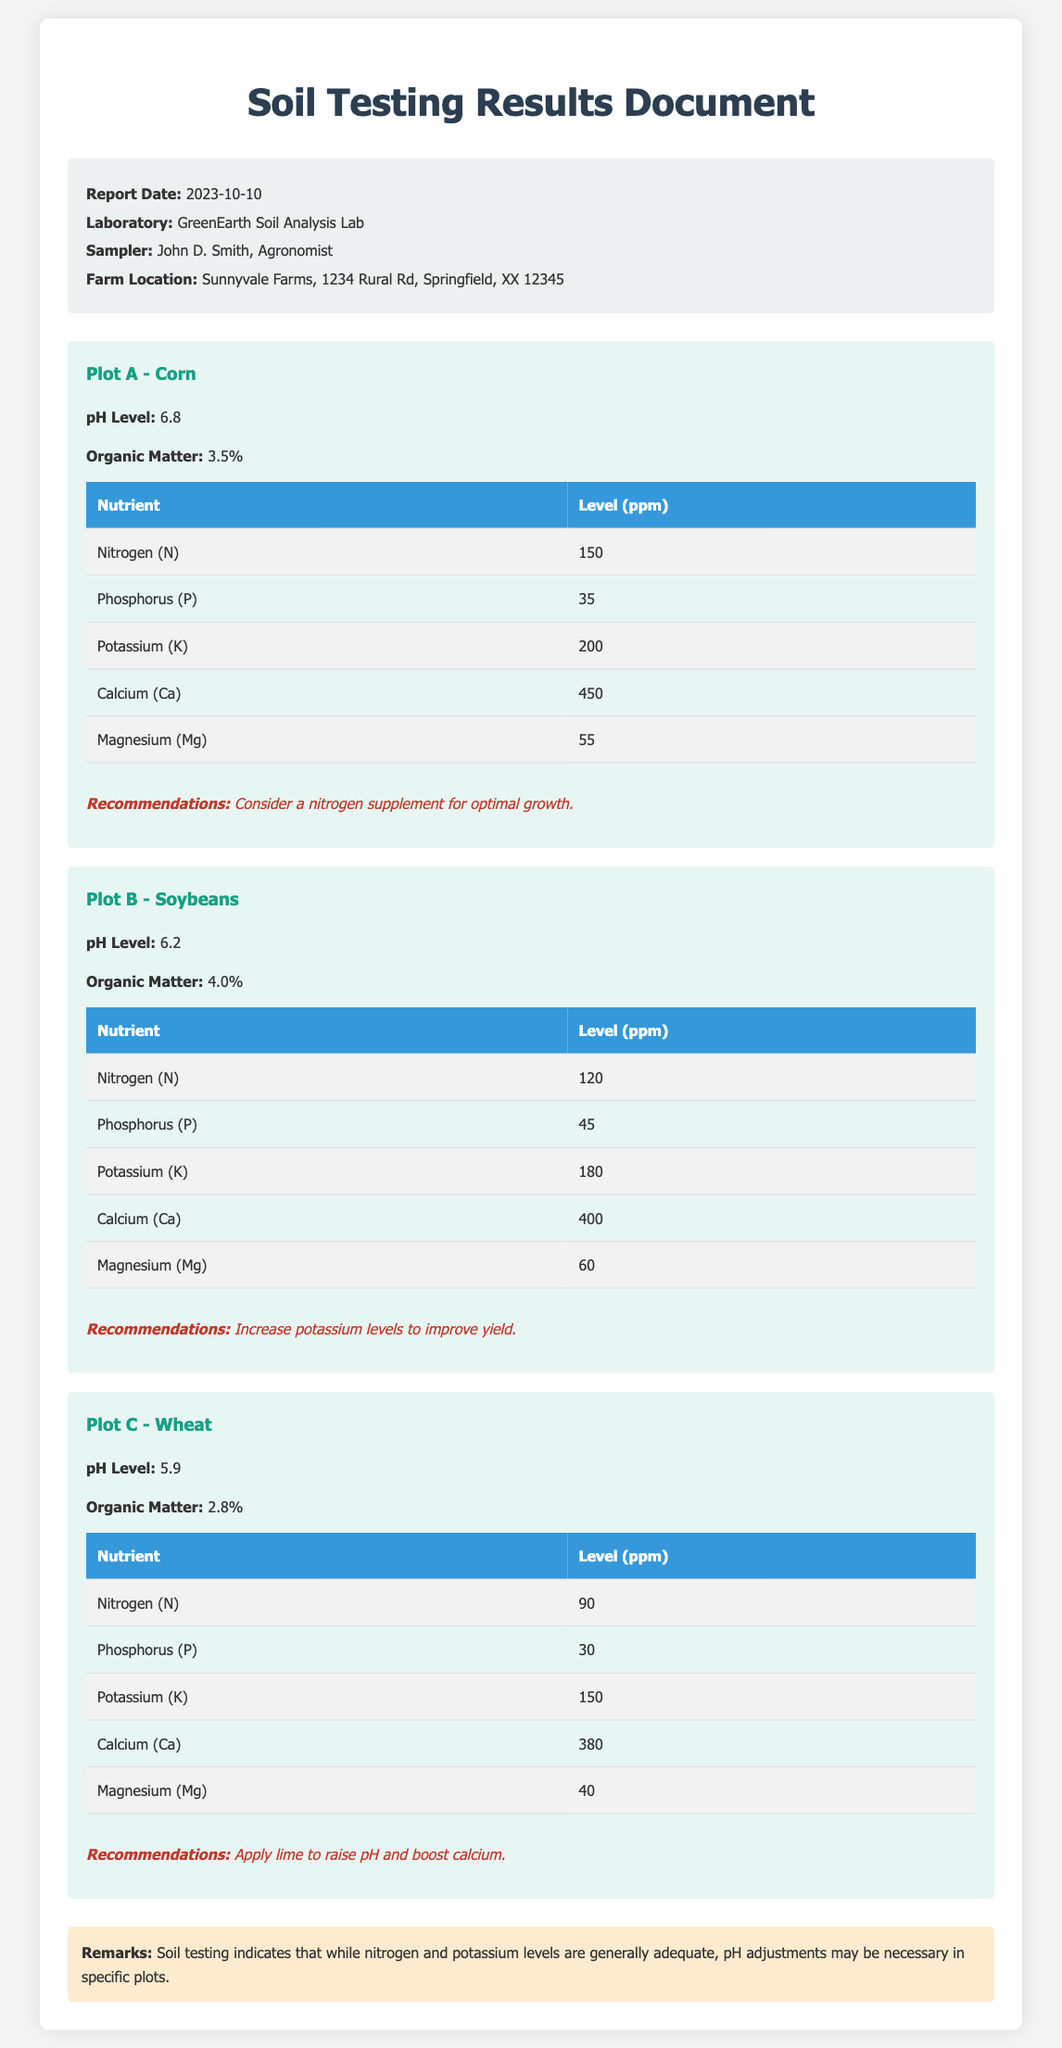What is the report date? The report date is mentioned in the header of the document as 2023-10-10.
Answer: 2023-10-10 What laboratory conducted the soil analysis? The document specifies that the laboratory is GreenEarth Soil Analysis Lab.
Answer: GreenEarth Soil Analysis Lab What is the pH level of Plot A? The pH level for Plot A is detailed in the section for Plot A as 6.8.
Answer: 6.8 What are the nitrogen levels in Plot B? The nitrogen level for Plot B is listed in the corresponding table as 120 ppm.
Answer: 120 ppm Which plot has the highest organic matter percentage? Comparing the organic matter percentages across the plots, Plot B has the highest organic matter at 4.0%.
Answer: 4.0% What recommendation is given for Plot C? The recommendation for Plot C mentions applying lime to raise pH and boost calcium.
Answer: Apply lime to raise pH and boost calcium How many plots are analyzed in the document? The document details soil testing results for three plots, A, B, and C.
Answer: Three plots Which nutrient is recommended to be increased in Plot B? The document specifically recommends increasing potassium levels in Plot B to improve yield.
Answer: Potassium levels What is the remark provided at the end of the document? The remarks at the end indicate that pH adjustments may be necessary in specific plots.
Answer: pH adjustments may be necessary in specific plots 